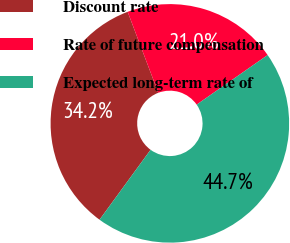Convert chart to OTSL. <chart><loc_0><loc_0><loc_500><loc_500><pie_chart><fcel>Discount rate<fcel>Rate of future compensation<fcel>Expected long-term rate of<nl><fcel>34.21%<fcel>21.05%<fcel>44.74%<nl></chart> 